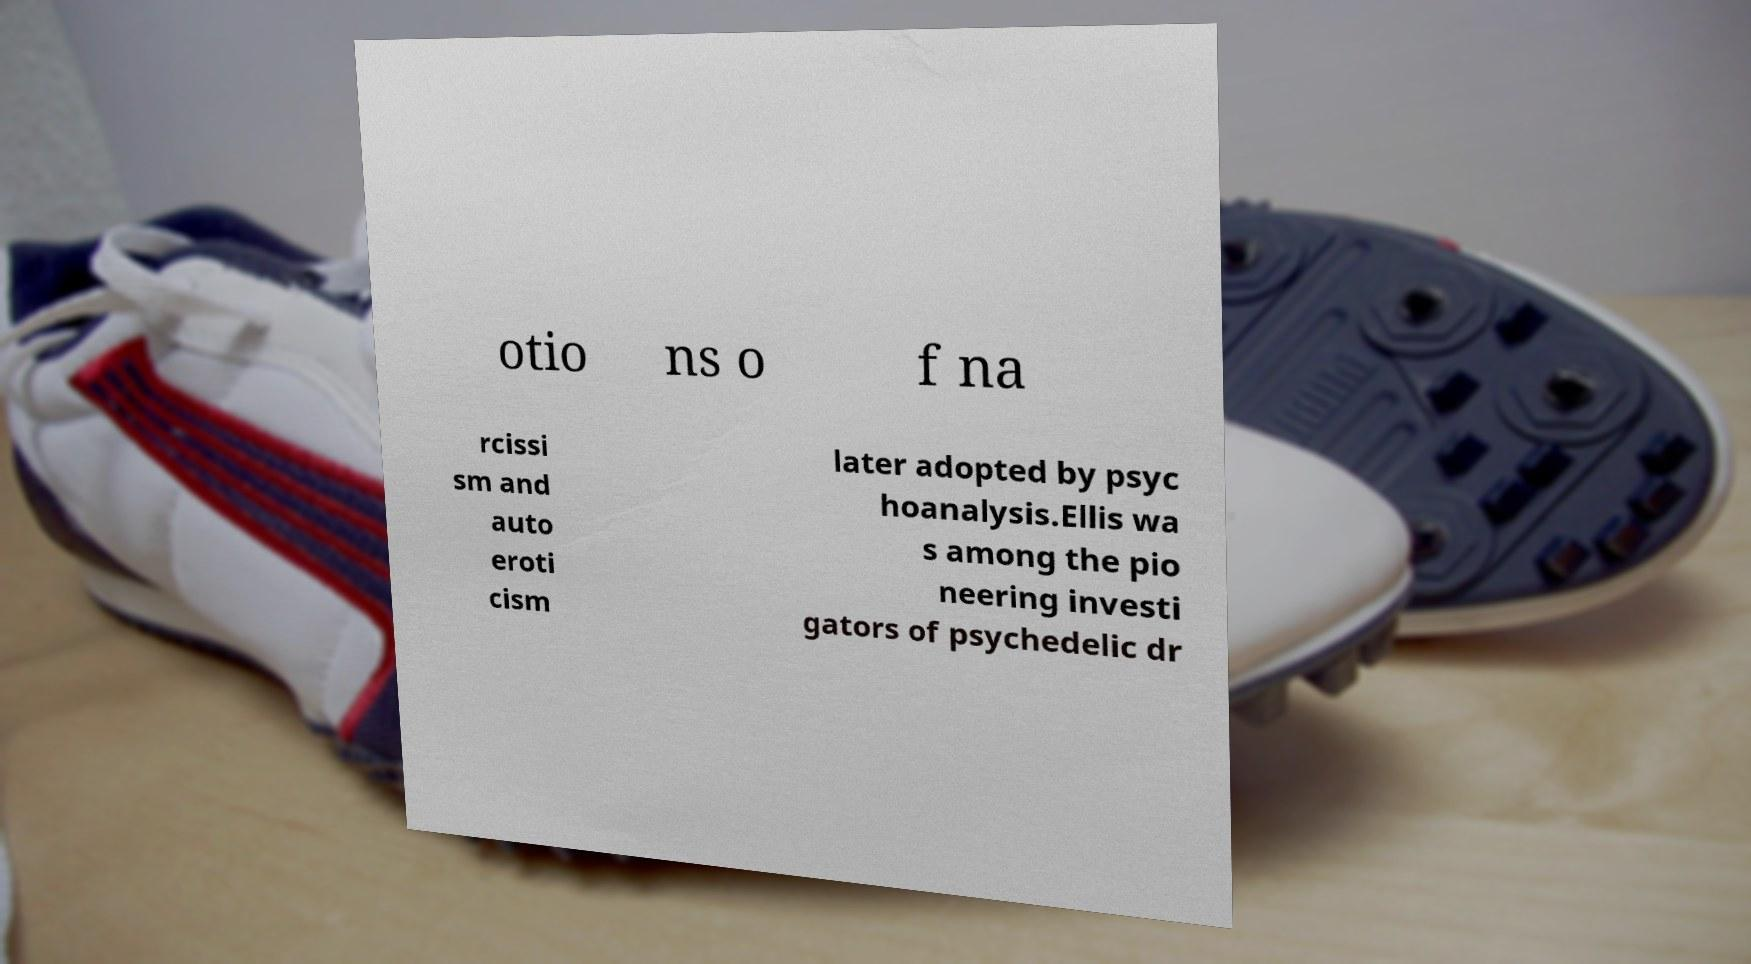Can you read and provide the text displayed in the image?This photo seems to have some interesting text. Can you extract and type it out for me? otio ns o f na rcissi sm and auto eroti cism later adopted by psyc hoanalysis.Ellis wa s among the pio neering investi gators of psychedelic dr 